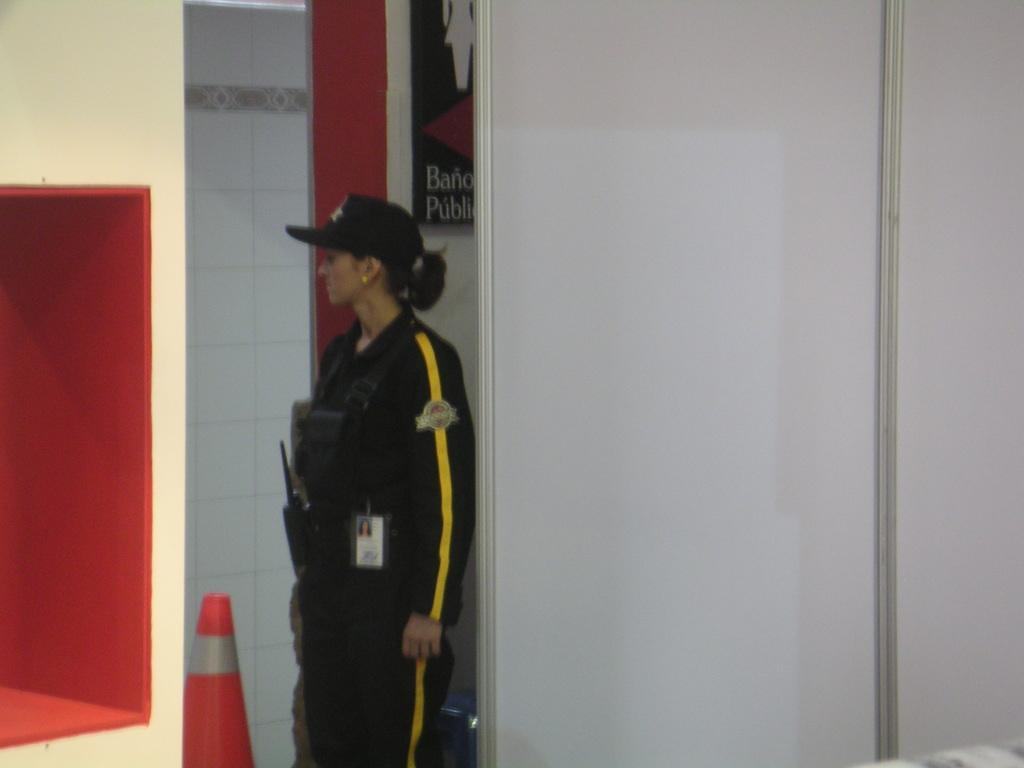Describe this image in one or two sentences. This is the woman standing. She wore a cap, jerkin and trouser. This looks like a badge. This is the board attached to the wall. I think this is the door, which is white in color. I can see an object's, which is orange in color. 